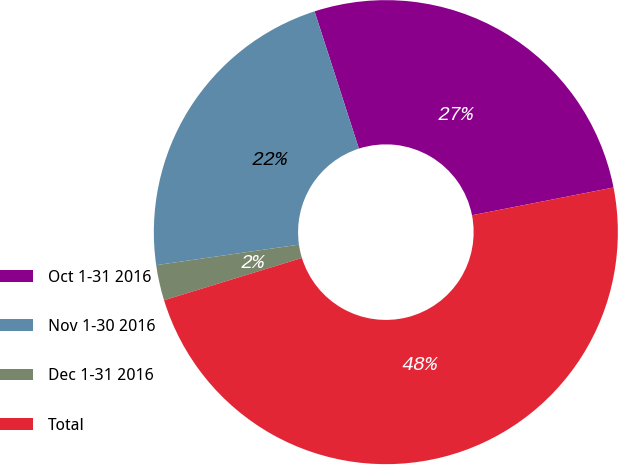Convert chart. <chart><loc_0><loc_0><loc_500><loc_500><pie_chart><fcel>Oct 1-31 2016<fcel>Nov 1-30 2016<fcel>Dec 1-31 2016<fcel>Total<nl><fcel>26.89%<fcel>22.3%<fcel>2.47%<fcel>48.34%<nl></chart> 